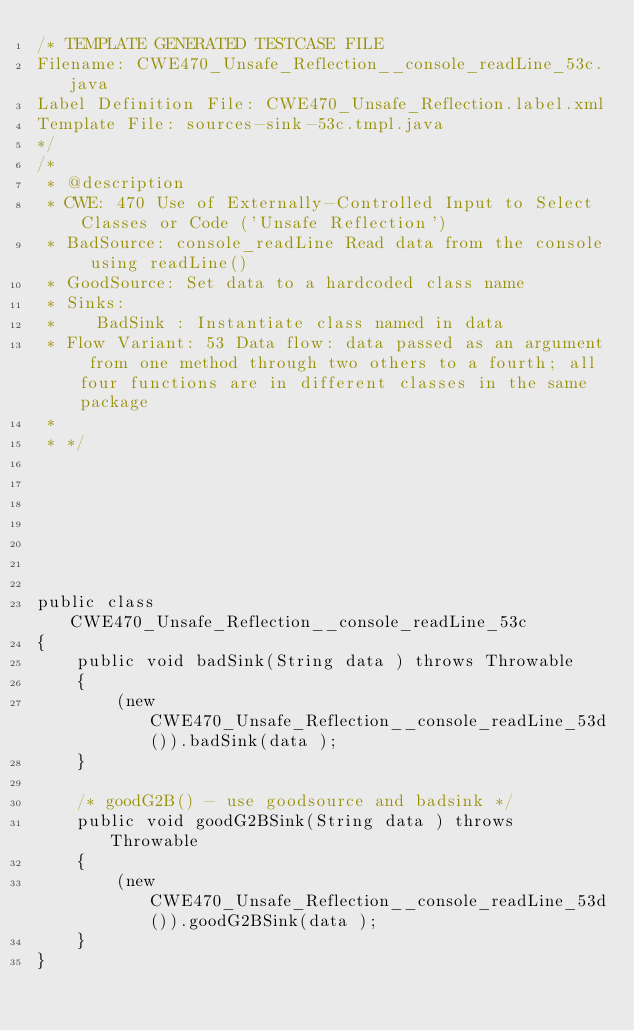<code> <loc_0><loc_0><loc_500><loc_500><_Java_>/* TEMPLATE GENERATED TESTCASE FILE
Filename: CWE470_Unsafe_Reflection__console_readLine_53c.java
Label Definition File: CWE470_Unsafe_Reflection.label.xml
Template File: sources-sink-53c.tmpl.java
*/
/*
 * @description
 * CWE: 470 Use of Externally-Controlled Input to Select Classes or Code ('Unsafe Reflection')
 * BadSource: console_readLine Read data from the console using readLine()
 * GoodSource: Set data to a hardcoded class name
 * Sinks:
 *    BadSink : Instantiate class named in data
 * Flow Variant: 53 Data flow: data passed as an argument from one method through two others to a fourth; all four functions are in different classes in the same package
 *
 * */







public class CWE470_Unsafe_Reflection__console_readLine_53c
{
    public void badSink(String data ) throws Throwable
    {
        (new CWE470_Unsafe_Reflection__console_readLine_53d()).badSink(data );
    }

    /* goodG2B() - use goodsource and badsink */
    public void goodG2BSink(String data ) throws Throwable
    {
        (new CWE470_Unsafe_Reflection__console_readLine_53d()).goodG2BSink(data );
    }
}
</code> 